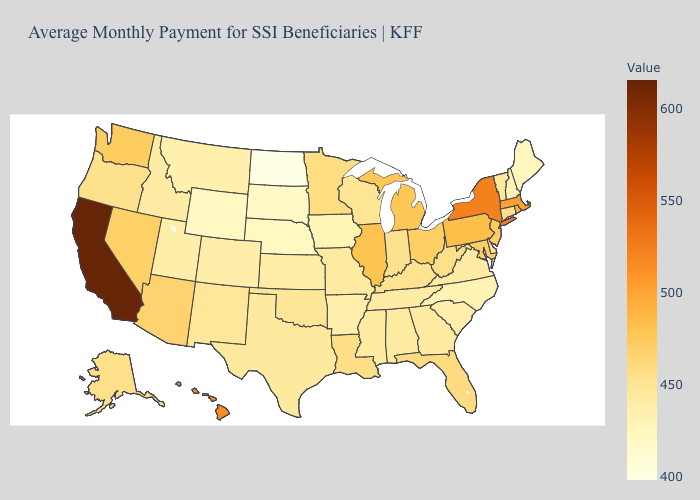Does Tennessee have the lowest value in the USA?
Concise answer only. No. Does Oklahoma have a lower value than South Dakota?
Answer briefly. No. Does the map have missing data?
Give a very brief answer. No. 